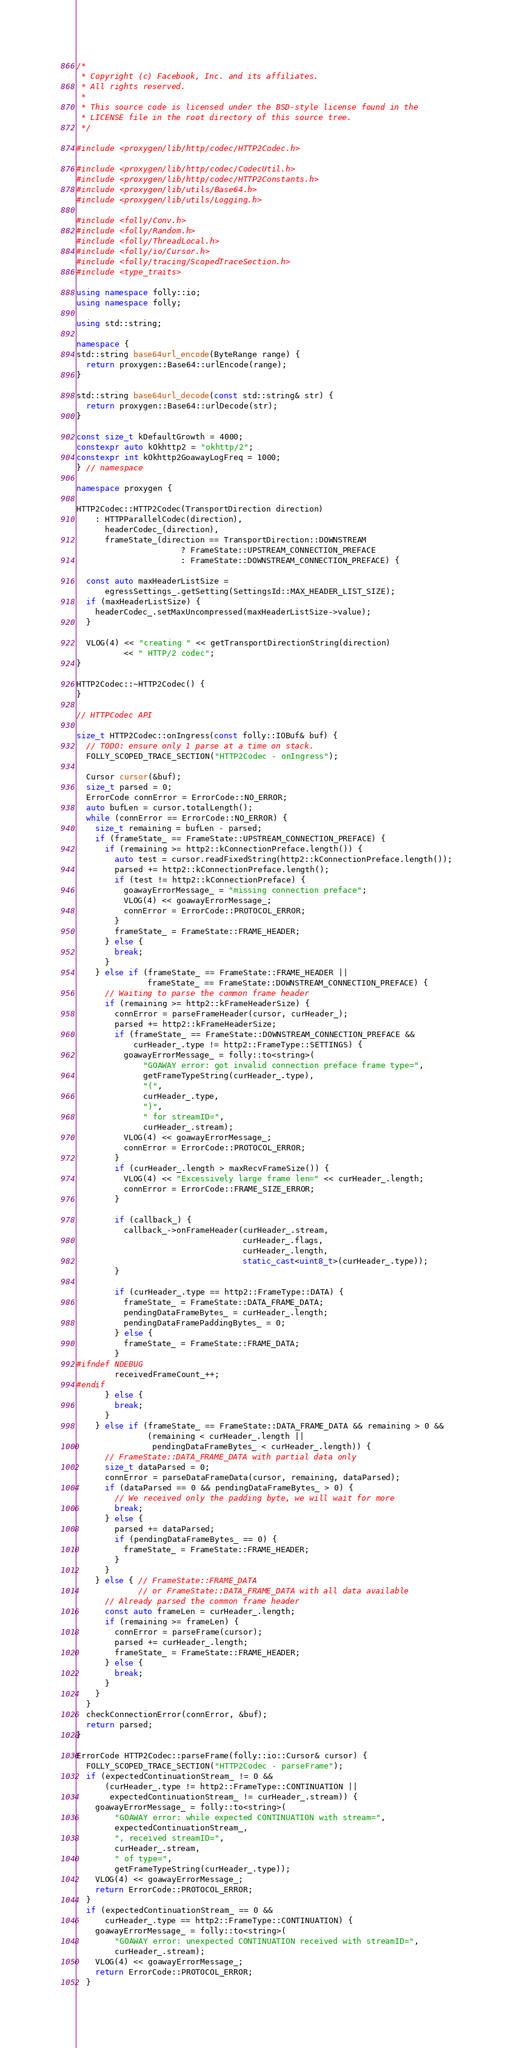<code> <loc_0><loc_0><loc_500><loc_500><_C++_>/*
 * Copyright (c) Facebook, Inc. and its affiliates.
 * All rights reserved.
 *
 * This source code is licensed under the BSD-style license found in the
 * LICENSE file in the root directory of this source tree.
 */

#include <proxygen/lib/http/codec/HTTP2Codec.h>

#include <proxygen/lib/http/codec/CodecUtil.h>
#include <proxygen/lib/http/codec/HTTP2Constants.h>
#include <proxygen/lib/utils/Base64.h>
#include <proxygen/lib/utils/Logging.h>

#include <folly/Conv.h>
#include <folly/Random.h>
#include <folly/ThreadLocal.h>
#include <folly/io/Cursor.h>
#include <folly/tracing/ScopedTraceSection.h>
#include <type_traits>

using namespace folly::io;
using namespace folly;

using std::string;

namespace {
std::string base64url_encode(ByteRange range) {
  return proxygen::Base64::urlEncode(range);
}

std::string base64url_decode(const std::string& str) {
  return proxygen::Base64::urlDecode(str);
}

const size_t kDefaultGrowth = 4000;
constexpr auto kOkhttp2 = "okhttp/2";
constexpr int kOkhttp2GoawayLogFreq = 1000;
} // namespace

namespace proxygen {

HTTP2Codec::HTTP2Codec(TransportDirection direction)
    : HTTPParallelCodec(direction),
      headerCodec_(direction),
      frameState_(direction == TransportDirection::DOWNSTREAM
                      ? FrameState::UPSTREAM_CONNECTION_PREFACE
                      : FrameState::DOWNSTREAM_CONNECTION_PREFACE) {

  const auto maxHeaderListSize =
      egressSettings_.getSetting(SettingsId::MAX_HEADER_LIST_SIZE);
  if (maxHeaderListSize) {
    headerCodec_.setMaxUncompressed(maxHeaderListSize->value);
  }

  VLOG(4) << "creating " << getTransportDirectionString(direction)
          << " HTTP/2 codec";
}

HTTP2Codec::~HTTP2Codec() {
}

// HTTPCodec API

size_t HTTP2Codec::onIngress(const folly::IOBuf& buf) {
  // TODO: ensure only 1 parse at a time on stack.
  FOLLY_SCOPED_TRACE_SECTION("HTTP2Codec - onIngress");

  Cursor cursor(&buf);
  size_t parsed = 0;
  ErrorCode connError = ErrorCode::NO_ERROR;
  auto bufLen = cursor.totalLength();
  while (connError == ErrorCode::NO_ERROR) {
    size_t remaining = bufLen - parsed;
    if (frameState_ == FrameState::UPSTREAM_CONNECTION_PREFACE) {
      if (remaining >= http2::kConnectionPreface.length()) {
        auto test = cursor.readFixedString(http2::kConnectionPreface.length());
        parsed += http2::kConnectionPreface.length();
        if (test != http2::kConnectionPreface) {
          goawayErrorMessage_ = "missing connection preface";
          VLOG(4) << goawayErrorMessage_;
          connError = ErrorCode::PROTOCOL_ERROR;
        }
        frameState_ = FrameState::FRAME_HEADER;
      } else {
        break;
      }
    } else if (frameState_ == FrameState::FRAME_HEADER ||
               frameState_ == FrameState::DOWNSTREAM_CONNECTION_PREFACE) {
      // Waiting to parse the common frame header
      if (remaining >= http2::kFrameHeaderSize) {
        connError = parseFrameHeader(cursor, curHeader_);
        parsed += http2::kFrameHeaderSize;
        if (frameState_ == FrameState::DOWNSTREAM_CONNECTION_PREFACE &&
            curHeader_.type != http2::FrameType::SETTINGS) {
          goawayErrorMessage_ = folly::to<string>(
              "GOAWAY error: got invalid connection preface frame type=",
              getFrameTypeString(curHeader_.type),
              "(",
              curHeader_.type,
              ")",
              " for streamID=",
              curHeader_.stream);
          VLOG(4) << goawayErrorMessage_;
          connError = ErrorCode::PROTOCOL_ERROR;
        }
        if (curHeader_.length > maxRecvFrameSize()) {
          VLOG(4) << "Excessively large frame len=" << curHeader_.length;
          connError = ErrorCode::FRAME_SIZE_ERROR;
        }

        if (callback_) {
          callback_->onFrameHeader(curHeader_.stream,
                                   curHeader_.flags,
                                   curHeader_.length,
                                   static_cast<uint8_t>(curHeader_.type));
        }

        if (curHeader_.type == http2::FrameType::DATA) {
          frameState_ = FrameState::DATA_FRAME_DATA;
          pendingDataFrameBytes_ = curHeader_.length;
          pendingDataFramePaddingBytes_ = 0;
        } else {
          frameState_ = FrameState::FRAME_DATA;
        }
#ifndef NDEBUG
        receivedFrameCount_++;
#endif
      } else {
        break;
      }
    } else if (frameState_ == FrameState::DATA_FRAME_DATA && remaining > 0 &&
               (remaining < curHeader_.length ||
                pendingDataFrameBytes_ < curHeader_.length)) {
      // FrameState::DATA_FRAME_DATA with partial data only
      size_t dataParsed = 0;
      connError = parseDataFrameData(cursor, remaining, dataParsed);
      if (dataParsed == 0 && pendingDataFrameBytes_ > 0) {
        // We received only the padding byte, we will wait for more
        break;
      } else {
        parsed += dataParsed;
        if (pendingDataFrameBytes_ == 0) {
          frameState_ = FrameState::FRAME_HEADER;
        }
      }
    } else { // FrameState::FRAME_DATA
             // or FrameState::DATA_FRAME_DATA with all data available
      // Already parsed the common frame header
      const auto frameLen = curHeader_.length;
      if (remaining >= frameLen) {
        connError = parseFrame(cursor);
        parsed += curHeader_.length;
        frameState_ = FrameState::FRAME_HEADER;
      } else {
        break;
      }
    }
  }
  checkConnectionError(connError, &buf);
  return parsed;
}

ErrorCode HTTP2Codec::parseFrame(folly::io::Cursor& cursor) {
  FOLLY_SCOPED_TRACE_SECTION("HTTP2Codec - parseFrame");
  if (expectedContinuationStream_ != 0 &&
      (curHeader_.type != http2::FrameType::CONTINUATION ||
       expectedContinuationStream_ != curHeader_.stream)) {
    goawayErrorMessage_ = folly::to<string>(
        "GOAWAY error: while expected CONTINUATION with stream=",
        expectedContinuationStream_,
        ", received streamID=",
        curHeader_.stream,
        " of type=",
        getFrameTypeString(curHeader_.type));
    VLOG(4) << goawayErrorMessage_;
    return ErrorCode::PROTOCOL_ERROR;
  }
  if (expectedContinuationStream_ == 0 &&
      curHeader_.type == http2::FrameType::CONTINUATION) {
    goawayErrorMessage_ = folly::to<string>(
        "GOAWAY error: unexpected CONTINUATION received with streamID=",
        curHeader_.stream);
    VLOG(4) << goawayErrorMessage_;
    return ErrorCode::PROTOCOL_ERROR;
  }</code> 